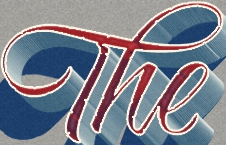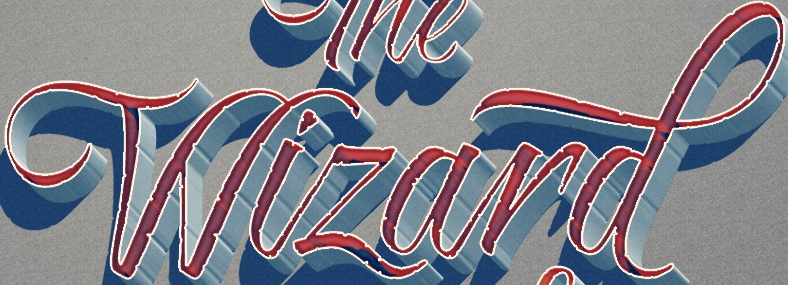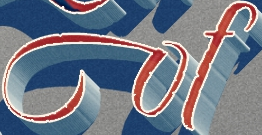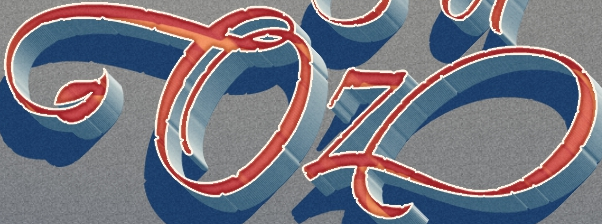What text is displayed in these images sequentially, separated by a semicolon? The; Wizard; of; Oz 